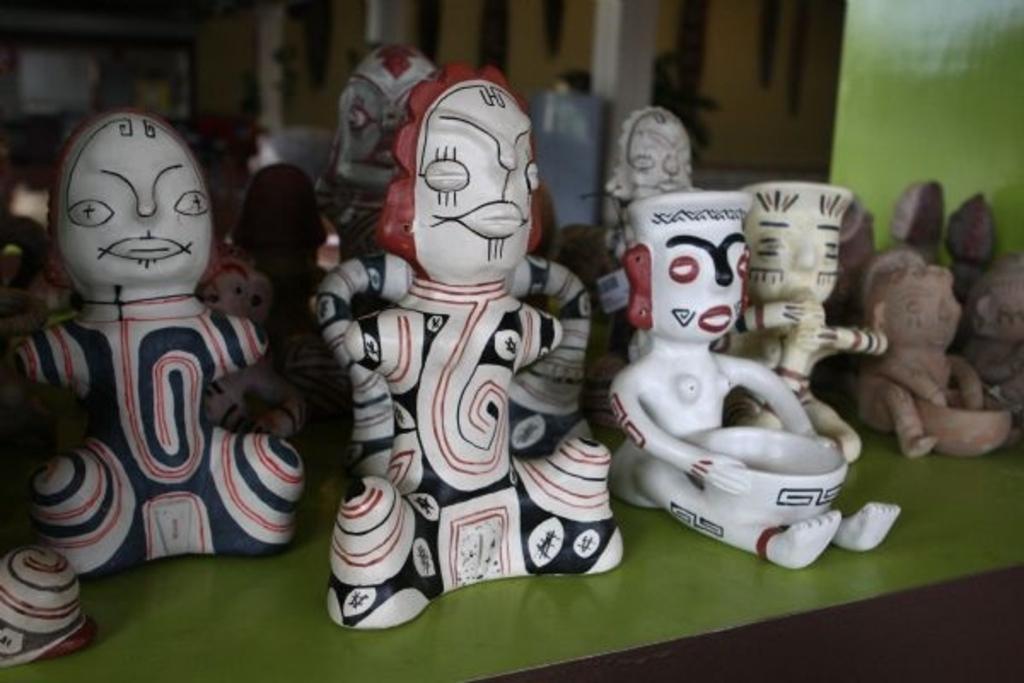Describe this image in one or two sentences. In this picture we can see dolls on a green platform and in the background we can see some objects and it is blurry. 